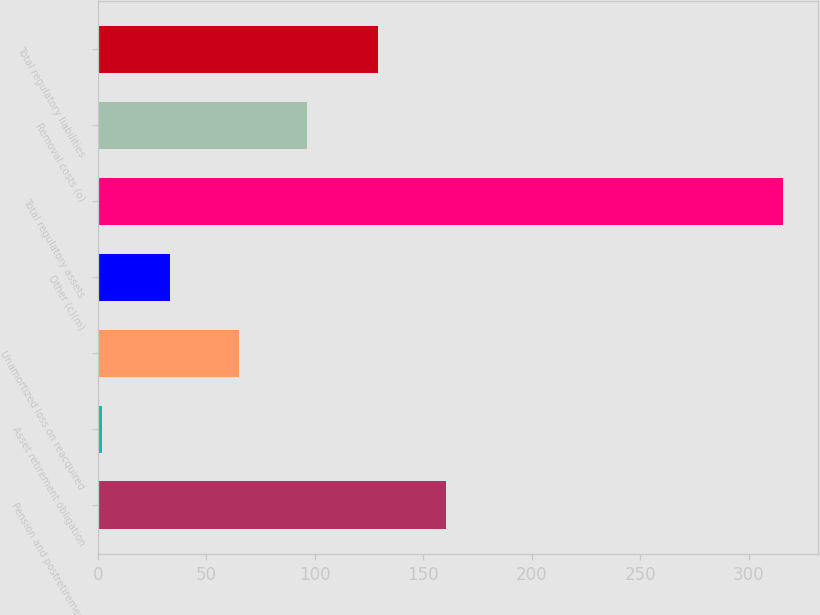Convert chart to OTSL. <chart><loc_0><loc_0><loc_500><loc_500><bar_chart><fcel>Pension and postretirement<fcel>Asset retirement obligation<fcel>Unamortized loss on reacquired<fcel>Other (c)(m)<fcel>Total regulatory assets<fcel>Removal costs (o)<fcel>Total regulatory liabilities<nl><fcel>160.4<fcel>2<fcel>64.8<fcel>33.4<fcel>316<fcel>96.2<fcel>129<nl></chart> 